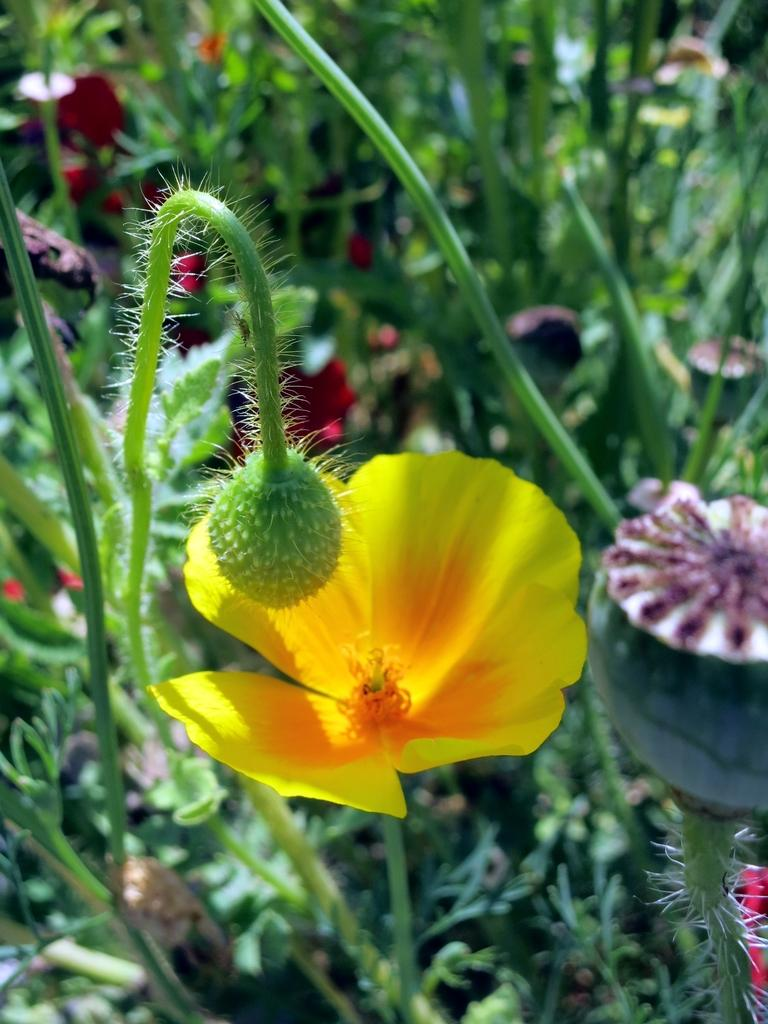What type of flower is on the plant in the image? There is a yellow flower on the plant in the image. What is the growth stage of the other flower on the plant? There is a bud on the plant in the image. What can be seen in the background of the image besides the plant? The background of the image includes flowers and leaves. What type of animal is causing a war in the image? There is no animal or war present in the image; it features a plant with a yellow flower and a bud. 